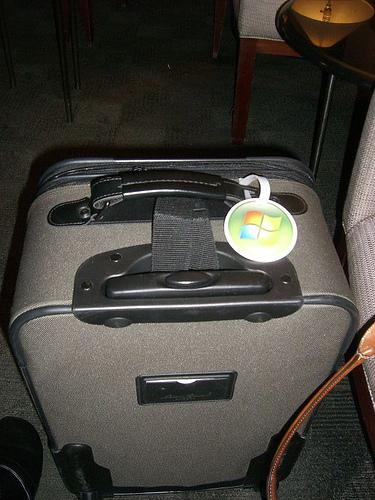How many colors in Microsoft Windows logo? four 